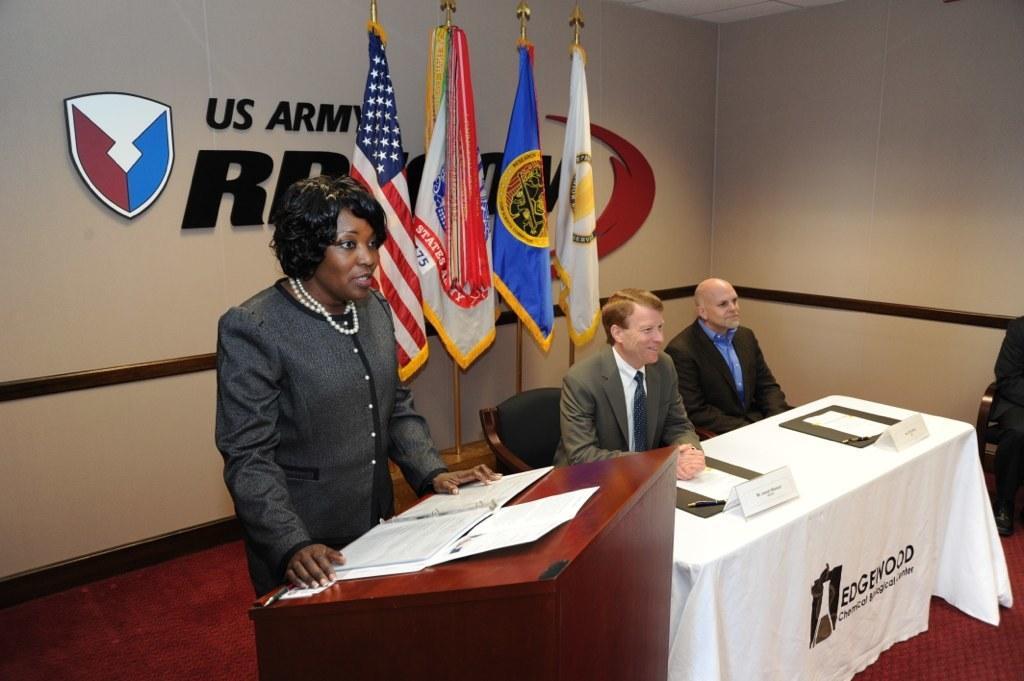Can you describe this image briefly? In this image we can see a woman wearing a black dress and pearl chain is standing near the podium where the papers are kept and these two persons are sitting on the chairs near the table where papers, pens and name boards with white color cloth is placed on it. Here we can see a chair, flags and logo with some text is fixed to the wall. 